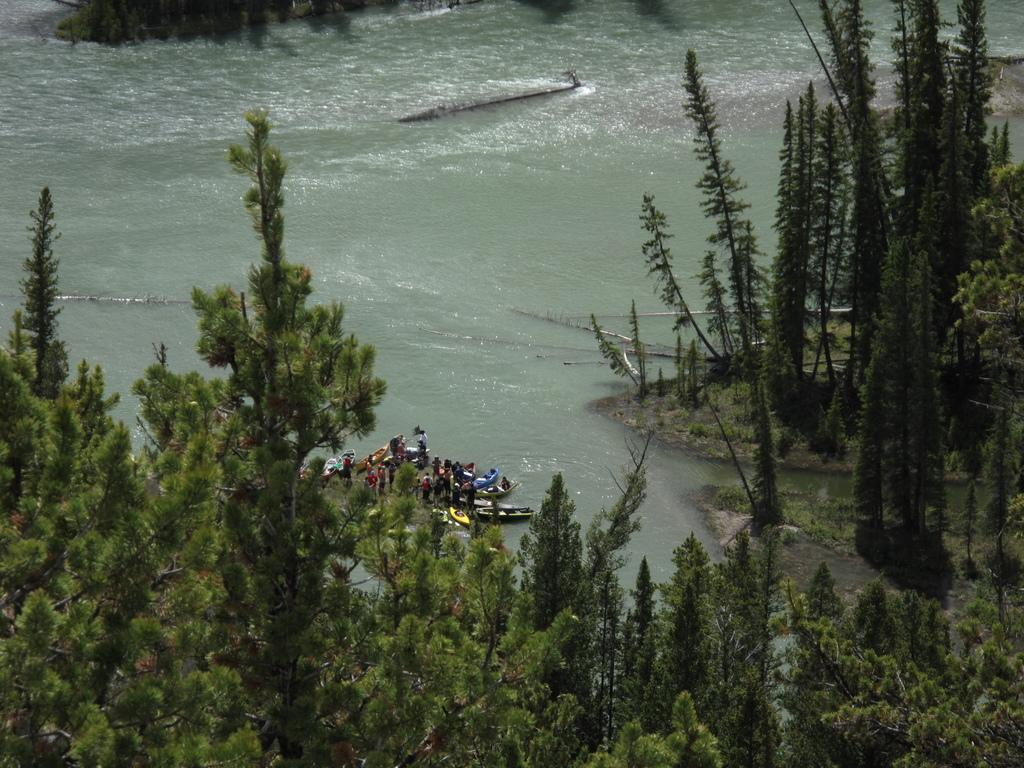What type of vegetation can be seen in the image? There are trees in the image. What is the boat's location in the image? The boat is on a river in the image. Are there any passengers on the boat? Yes, there are people on the boat in the image. What is the mass of the patch visible on the boat? There is no patch visible on the boat in the image. What is the range of the trees in the image? The range of the trees cannot be determined from the image, as it only shows a snapshot of the trees' location. 